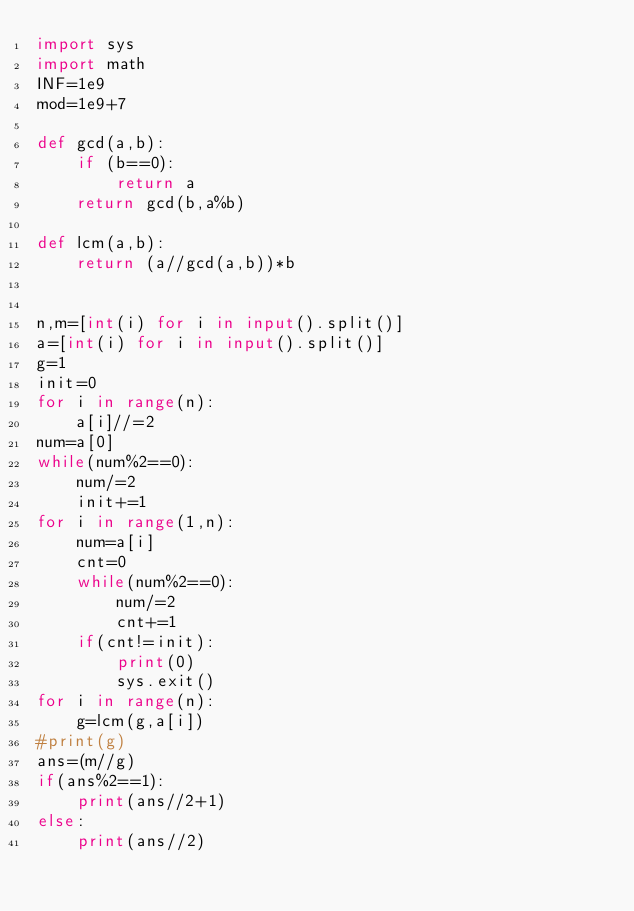<code> <loc_0><loc_0><loc_500><loc_500><_Python_>import sys
import math
INF=1e9
mod=1e9+7

def gcd(a,b):
    if (b==0):
        return a
    return gcd(b,a%b)
 
def lcm(a,b):
    return (a//gcd(a,b))*b
 

n,m=[int(i) for i in input().split()]
a=[int(i) for i in input().split()]
g=1
init=0
for i in range(n):
    a[i]//=2
num=a[0]
while(num%2==0):
    num/=2
    init+=1
for i in range(1,n):
    num=a[i]
    cnt=0
    while(num%2==0):
        num/=2
        cnt+=1
    if(cnt!=init):
        print(0)
        sys.exit()
for i in range(n):
    g=lcm(g,a[i])
#print(g)
ans=(m//g)
if(ans%2==1):
    print(ans//2+1)
else:
    print(ans//2)</code> 